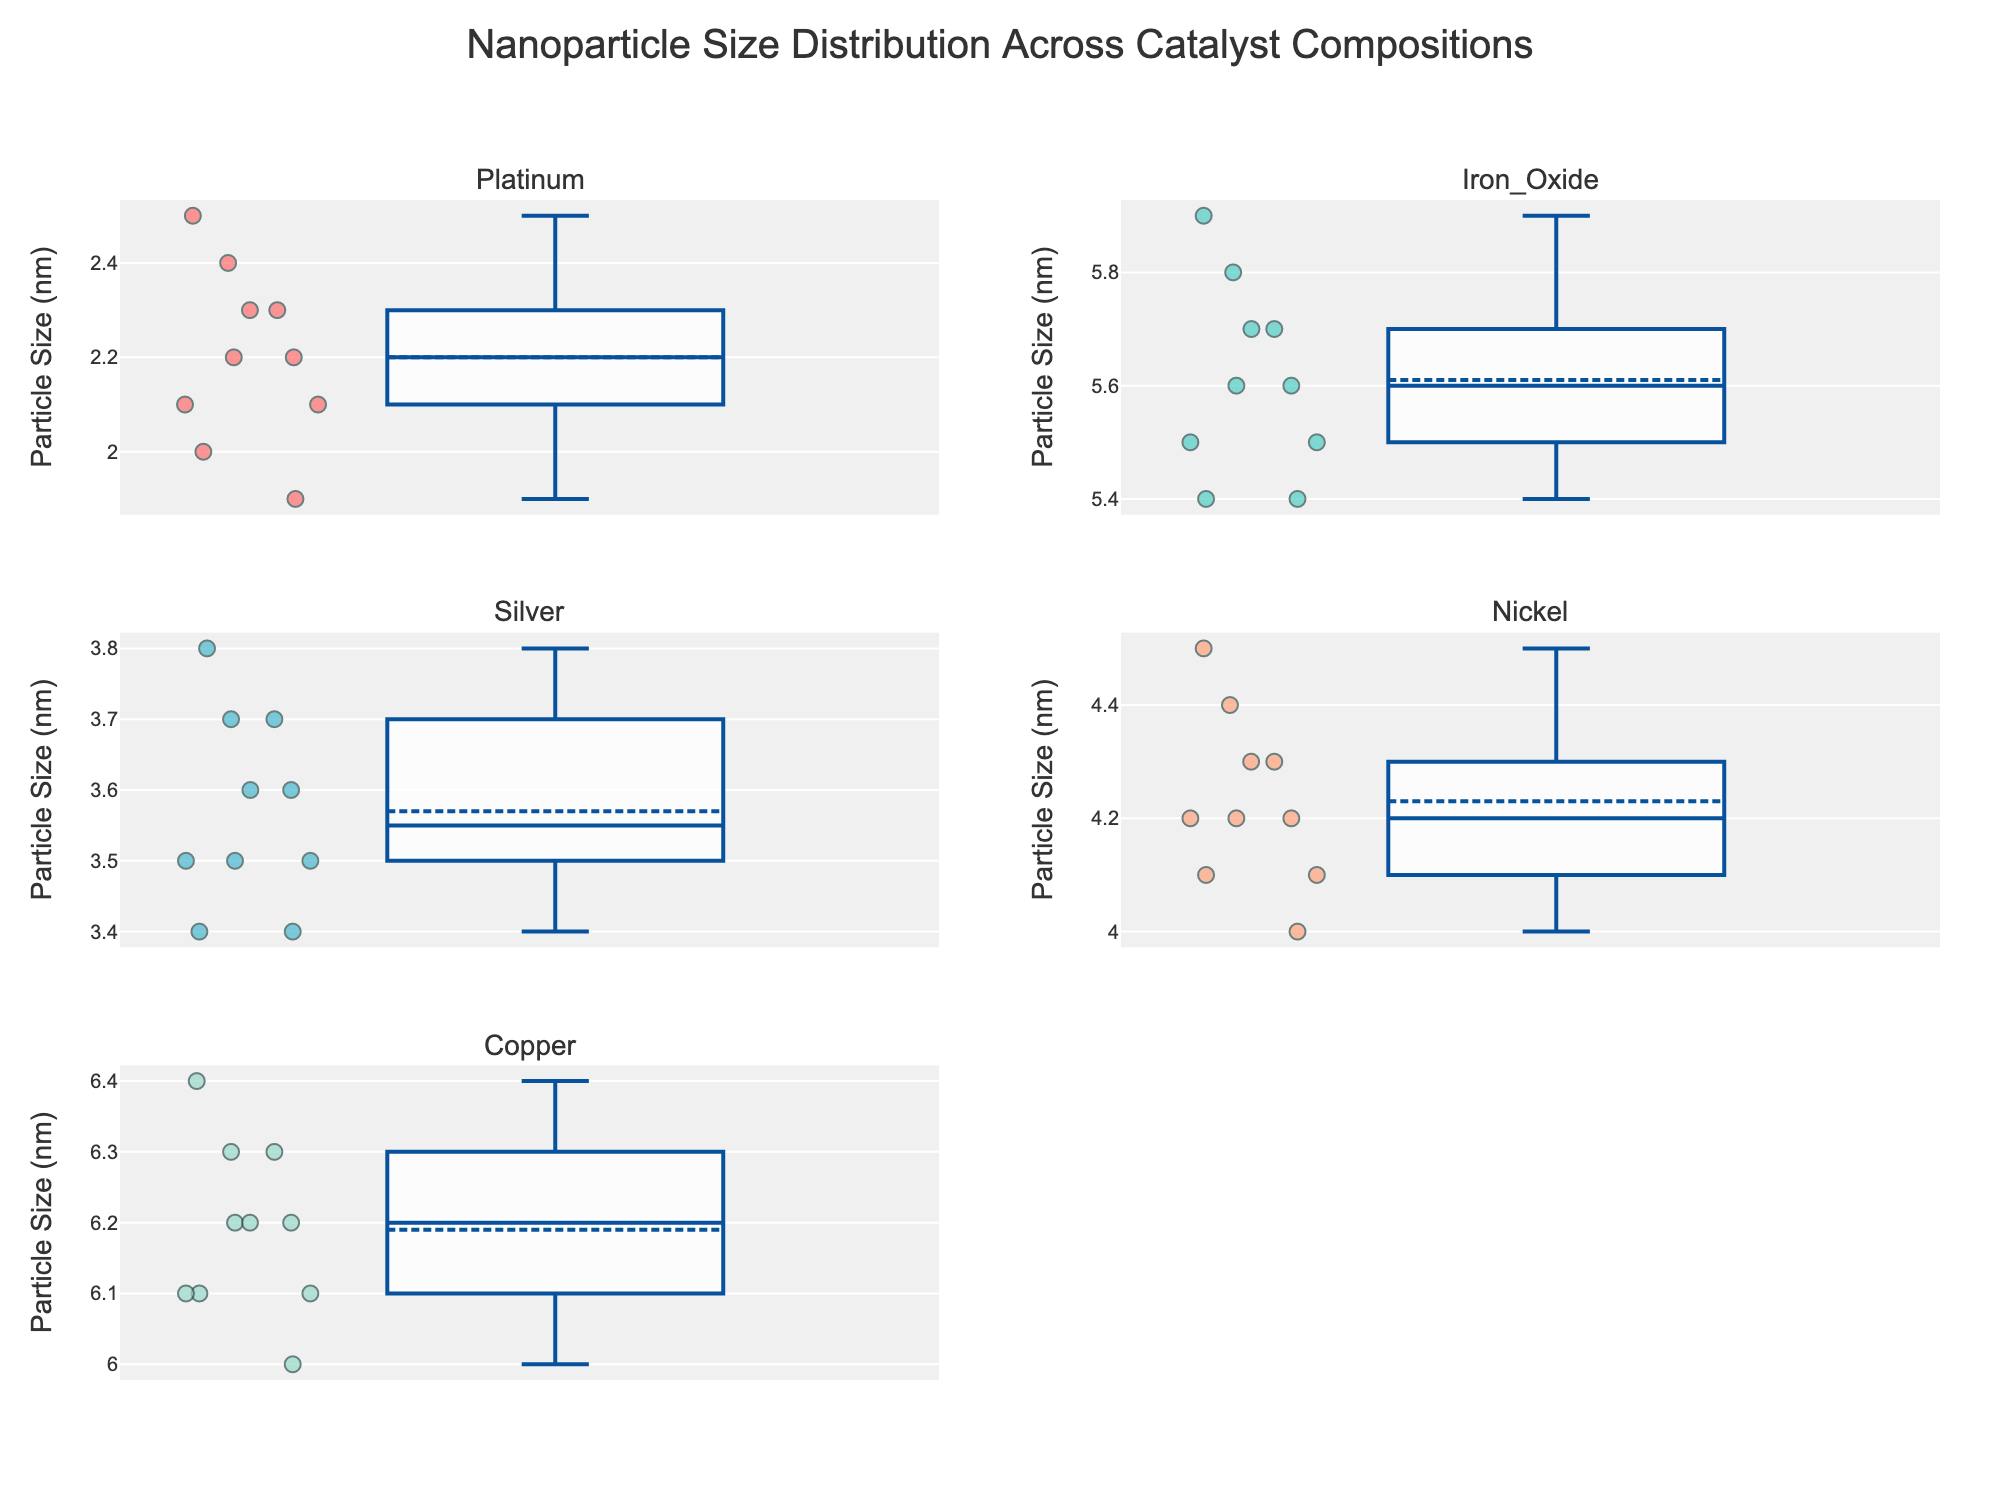What is the title of the figure? The title of the figure is located at the top. It states, 'Nanoparticle Size Distribution Across Catalyst Compositions'.
Answer: Nanoparticle Size Distribution Across Catalyst Compositions Which catalyst has the smallest median nanoparticle size? By observing the median lines in the box plots, the platinum catalyst has the smallest median nanoparticle size.
Answer: Platinum What is the range of particle sizes for the Nickel catalyst? The whiskers of the box plot for Nickel extend from 4.0 nm to 4.5 nm.
Answer: 4.0 nm to 4.5 nm Which catalyst shows the largest variability in particle size distribution? The range from the minimum to the maximum value in the box plot indicates variability. Copper has the largest range among the given catalysts, approximately from 6.0 nm to 6.4 nm.
Answer: Copper What is the shape of the distribution for the Iron Oxide catalyst based on the box plot? The box plot for Iron Oxide is relatively symmetrical, indicating a normal distribution since the median is nearly centered and whiskers are of similar length.
Answer: Symmetrical Compare the median nanoparticle size between Silver and Nickel. Which one is larger? The median line for Silver is at 3.5 nm while Nickel is around 4.2 nm. Thus, Nickel has a larger median nanoparticle size.
Answer: Nickel Which catalyst has the second smallest median nanoparticle size? From the box plot medians, Platinum has the smallest, and Silver has the second smallest median nanoparticle size, around 3.5 nm.
Answer: Silver Does the Platinum catalyst show any outliers in its nanoparticle size distribution? There are no points outside the whiskers in the Platinum box plot, meaning there are no outliers.
Answer: No How do the interquartile ranges (IQR) of Silver and Copper compare? The IQR is the length of the box. Silver's IQR is narrow, approximately 3.4 nm to 3.7 nm. Copper's IQR is wider, approximately 6.1 nm to 6.3 nm. Copper has a wider IQR than Silver.
Answer: Copper's IQR is wider Which catalyst has the highest upper whisker limit? By looking at the ends of the upper whiskers, Iron Oxide has the highest limit at around 5.9 nm.
Answer: Iron Oxide 